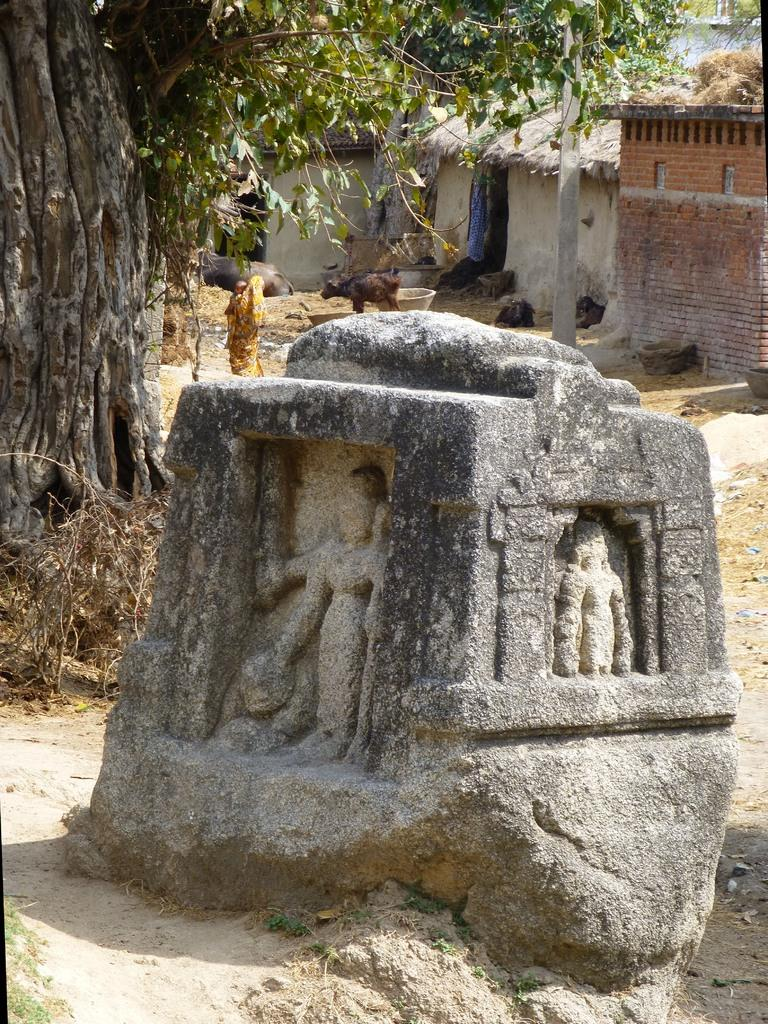What is located on the rock in the image? There are sculptures on a rock in the image. What can be seen in the distance behind the rock? There are houses and trees in the background of the image. What other unspecified objects can be seen in the background of the image? There are other unspecified objects in the background of the image. What rule does the creator of the sculptures follow when creating their art? There is no information provided about the creator of the sculptures or any rules they may follow, so this cannot be answered definitively. 